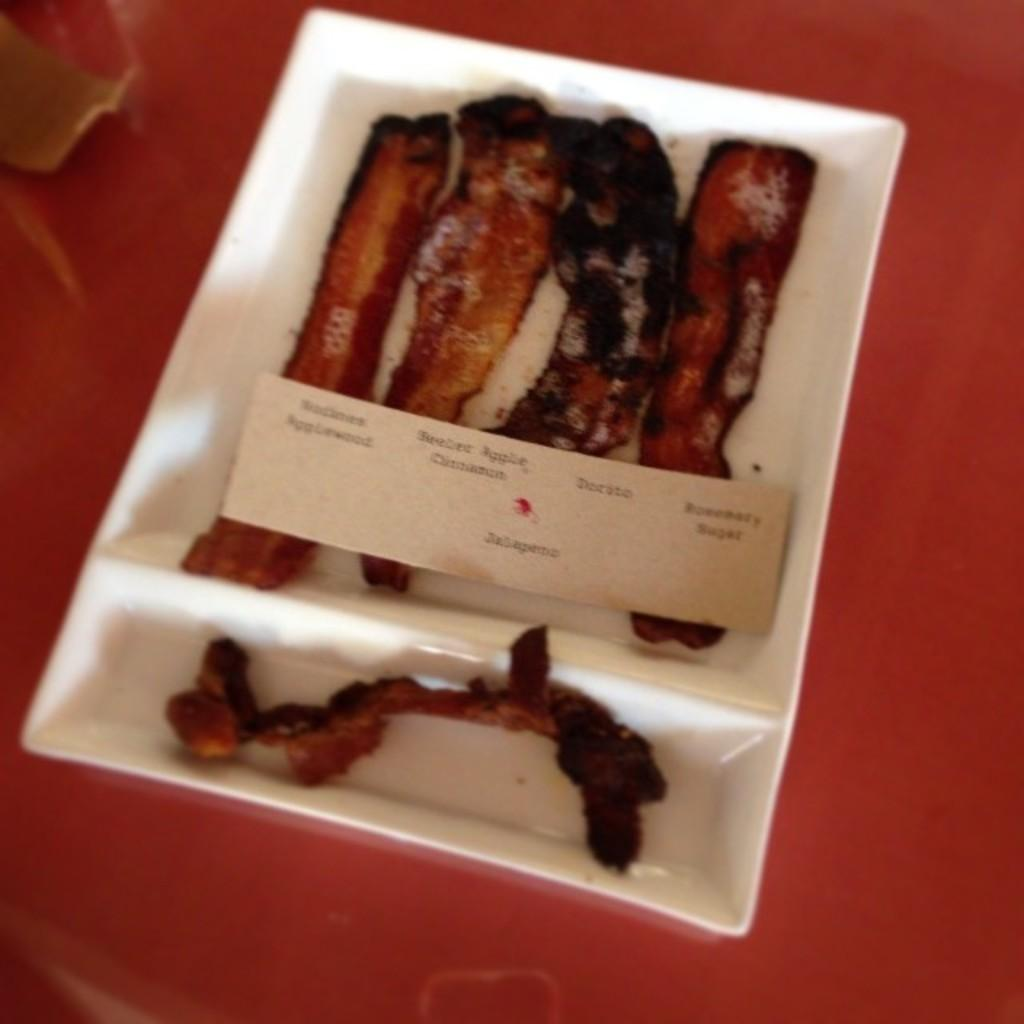What type of food is visible in the image? There are fried meat pieces in the image. How are the fried meat pieces arranged or presented? The fried meat pieces are in a white plate. What color is the floor in the image? The floor in the image is red. How many potatoes are being used as an attraction for women in the image? There are no potatoes or any attractions for women present in the image. 